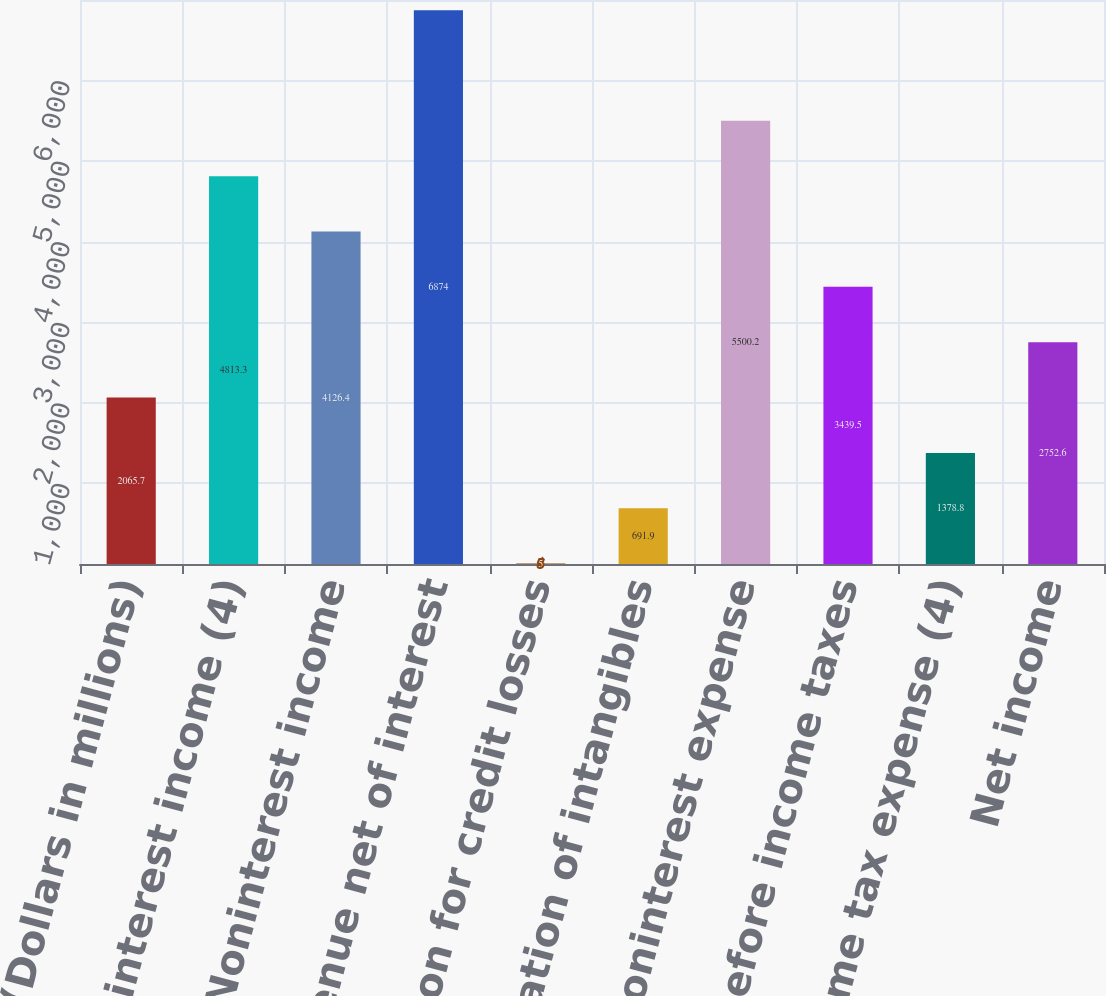Convert chart. <chart><loc_0><loc_0><loc_500><loc_500><bar_chart><fcel>(Dollars in millions)<fcel>Net interest income (4)<fcel>Noninterest income<fcel>Total revenue net of interest<fcel>Provision for credit losses<fcel>Amortization of intangibles<fcel>Other noninterest expense<fcel>Income before income taxes<fcel>Income tax expense (4)<fcel>Net income<nl><fcel>2065.7<fcel>4813.3<fcel>4126.4<fcel>6874<fcel>5<fcel>691.9<fcel>5500.2<fcel>3439.5<fcel>1378.8<fcel>2752.6<nl></chart> 